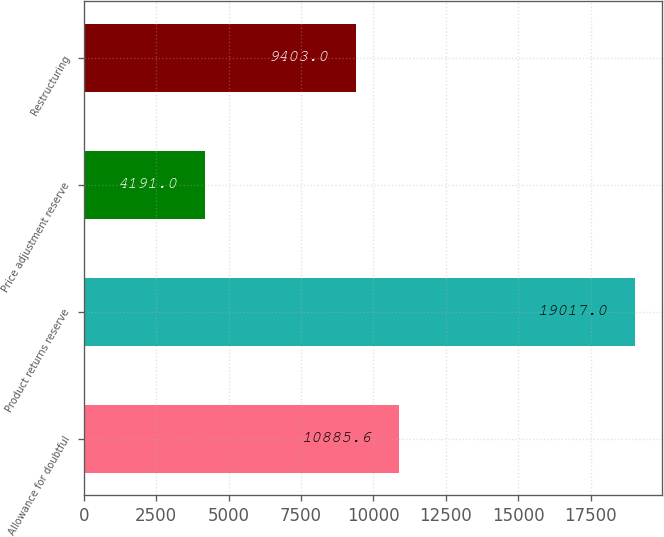Convert chart. <chart><loc_0><loc_0><loc_500><loc_500><bar_chart><fcel>Allowance for doubtful<fcel>Product returns reserve<fcel>Price adjustment reserve<fcel>Restructuring<nl><fcel>10885.6<fcel>19017<fcel>4191<fcel>9403<nl></chart> 